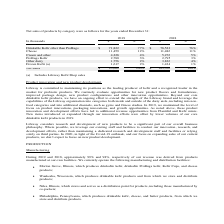From Lifeway Foods's financial document, What is the percentage of net sales from Cheese in 2018 and 2019 respectively? The document shows two values: 11% and 12%. From the document: "Cheese 11,459 12% 11,486 11% Cheese 11,459 12% 11,486 11%..." Also, What is the amount of net sales from ProBugs Kelir in 2018 and 2019 respectively? The document shows two values: 2,795 and 2,780 (in thousands). From the document: "ProBugs Kefir 2,780 3% 2,795 3% ProBugs Kefir 2,780 3% 2,795 3%..." Also, What does the table show? Net sales of products by category were as follows for the years ended December 31. The document states: "Net sales of products by category were as follows for the years ended December 31: 2019 2018..." Also, can you calculate: What is the difference in net sales between drinkable Kefir other than ProBugs and Cheese in 2019? Based on the calculation: 71,822-11,459, the result is 60363 (in thousands). This is based on the information: "Drinkable Kefir other than ProBugs $ 71,822 77% $ 78,523 76% Cheese 11,459 12% 11,486 11%..." The key data points involved are: 11,459, 71,822. Also, can you calculate: What is the average total net sales for both 2018 and 2019? To answer this question, I need to perform calculations using the financial data. The calculation is: (93,662+103,350)/2, which equals 98506 (in thousands). This is based on the information: "Net Sales $ 93,662 100% $ 103,350 100% Net Sales $ 93,662 100% $ 103,350 100%..." The key data points involved are: 103,350, 93,662. Also, can you calculate: What is the percentage constitution of net sales from Frozen Kefir among the total net sales in 2019? Based on the calculation: 1,617/93,662, the result is 1.73 (percentage). This is based on the information: "Net Sales $ 93,662 100% $ 103,350 100% Frozen Kefir (a) 1,617 2% 1,434 1%..." The key data points involved are: 1,617, 93,662. 